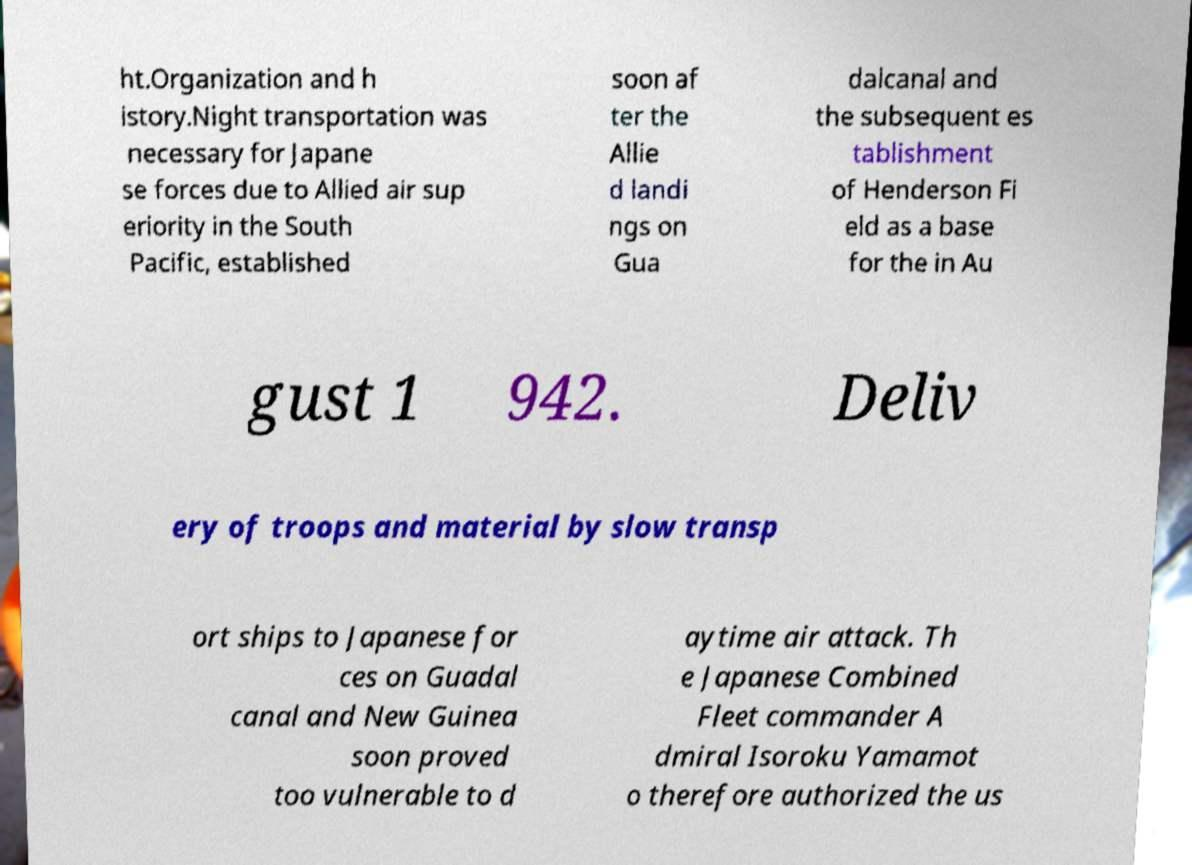For documentation purposes, I need the text within this image transcribed. Could you provide that? ht.Organization and h istory.Night transportation was necessary for Japane se forces due to Allied air sup eriority in the South Pacific, established soon af ter the Allie d landi ngs on Gua dalcanal and the subsequent es tablishment of Henderson Fi eld as a base for the in Au gust 1 942. Deliv ery of troops and material by slow transp ort ships to Japanese for ces on Guadal canal and New Guinea soon proved too vulnerable to d aytime air attack. Th e Japanese Combined Fleet commander A dmiral Isoroku Yamamot o therefore authorized the us 